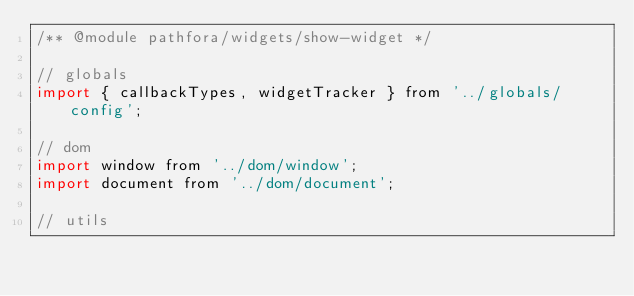<code> <loc_0><loc_0><loc_500><loc_500><_JavaScript_>/** @module pathfora/widgets/show-widget */

// globals
import { callbackTypes, widgetTracker } from '../globals/config';

// dom
import window from '../dom/window';
import document from '../dom/document';

// utils</code> 